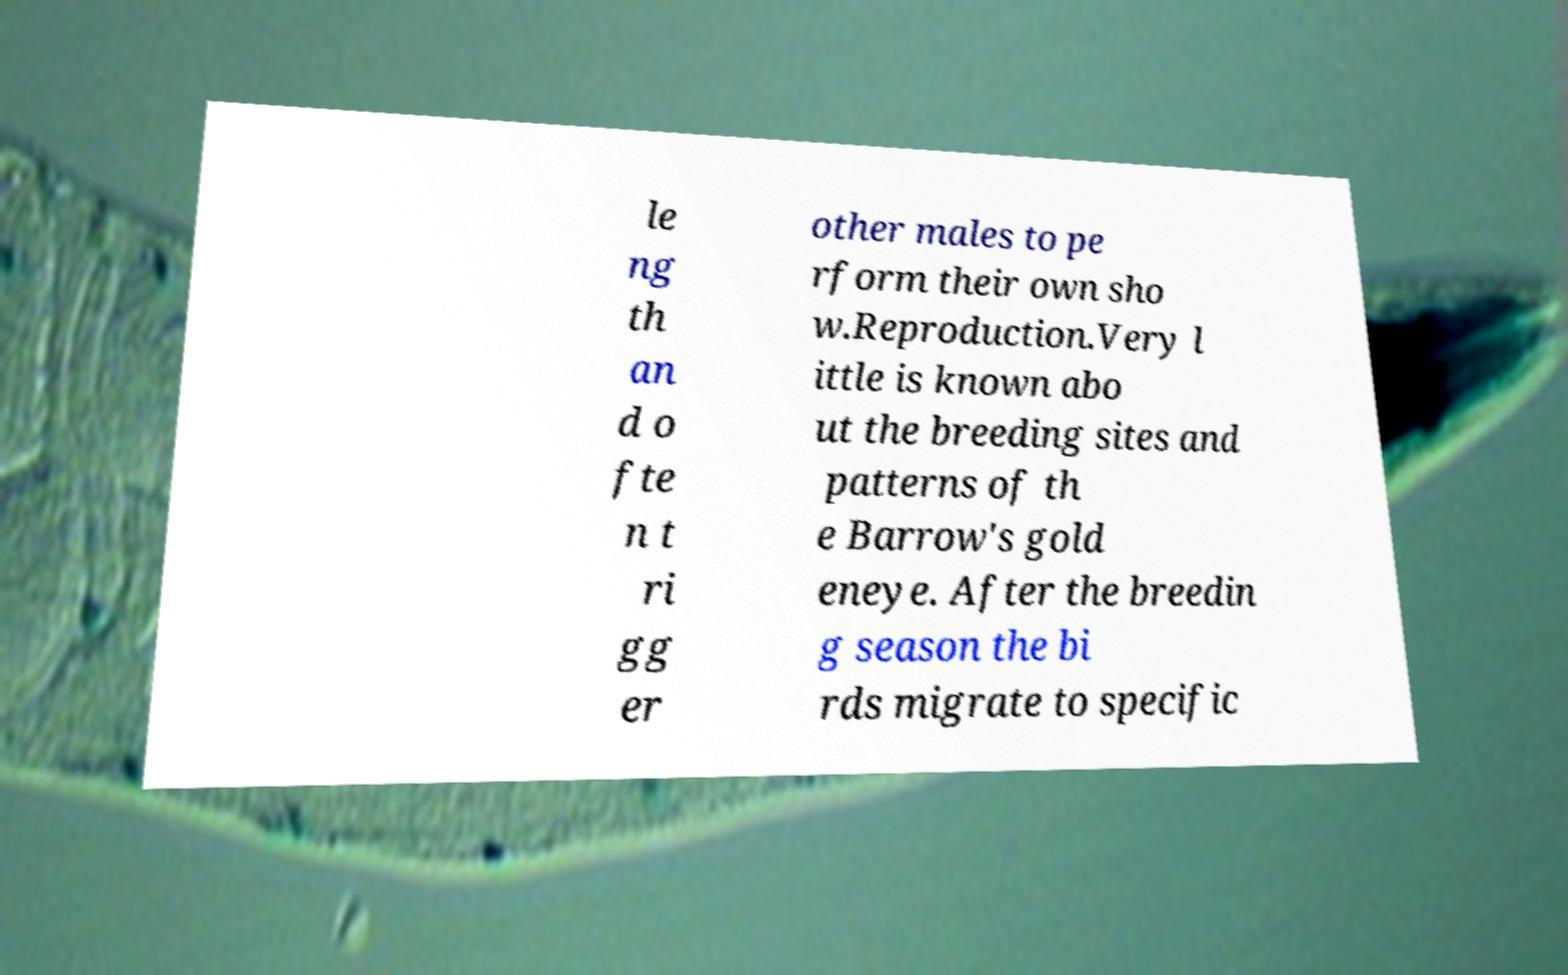What messages or text are displayed in this image? I need them in a readable, typed format. le ng th an d o fte n t ri gg er other males to pe rform their own sho w.Reproduction.Very l ittle is known abo ut the breeding sites and patterns of th e Barrow's gold eneye. After the breedin g season the bi rds migrate to specific 